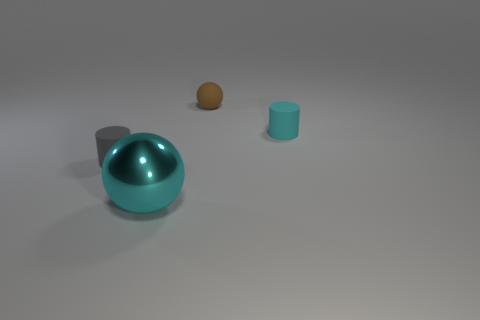What number of large objects are either gray matte objects or cyan spheres?
Offer a very short reply. 1. Is there any other thing that is the same color as the large shiny sphere?
Make the answer very short. Yes. There is a shiny sphere; are there any large metal things behind it?
Your answer should be very brief. No. There is a cylinder in front of the rubber cylinder that is right of the brown rubber object; how big is it?
Your answer should be very brief. Small. Are there the same number of cyan objects behind the brown thing and brown spheres on the left side of the tiny gray thing?
Provide a succinct answer. Yes. There is a cyan thing that is behind the tiny gray cylinder; are there any tiny brown matte objects that are to the right of it?
Your response must be concise. No. How many gray cylinders are behind the small rubber thing behind the cylinder that is to the right of the large ball?
Offer a terse response. 0. Are there fewer tiny gray matte things than objects?
Your answer should be very brief. Yes. Is the shape of the cyan thing behind the cyan metallic sphere the same as the small brown rubber thing to the right of the large metallic ball?
Provide a short and direct response. No. What color is the metal object?
Your answer should be compact. Cyan. 